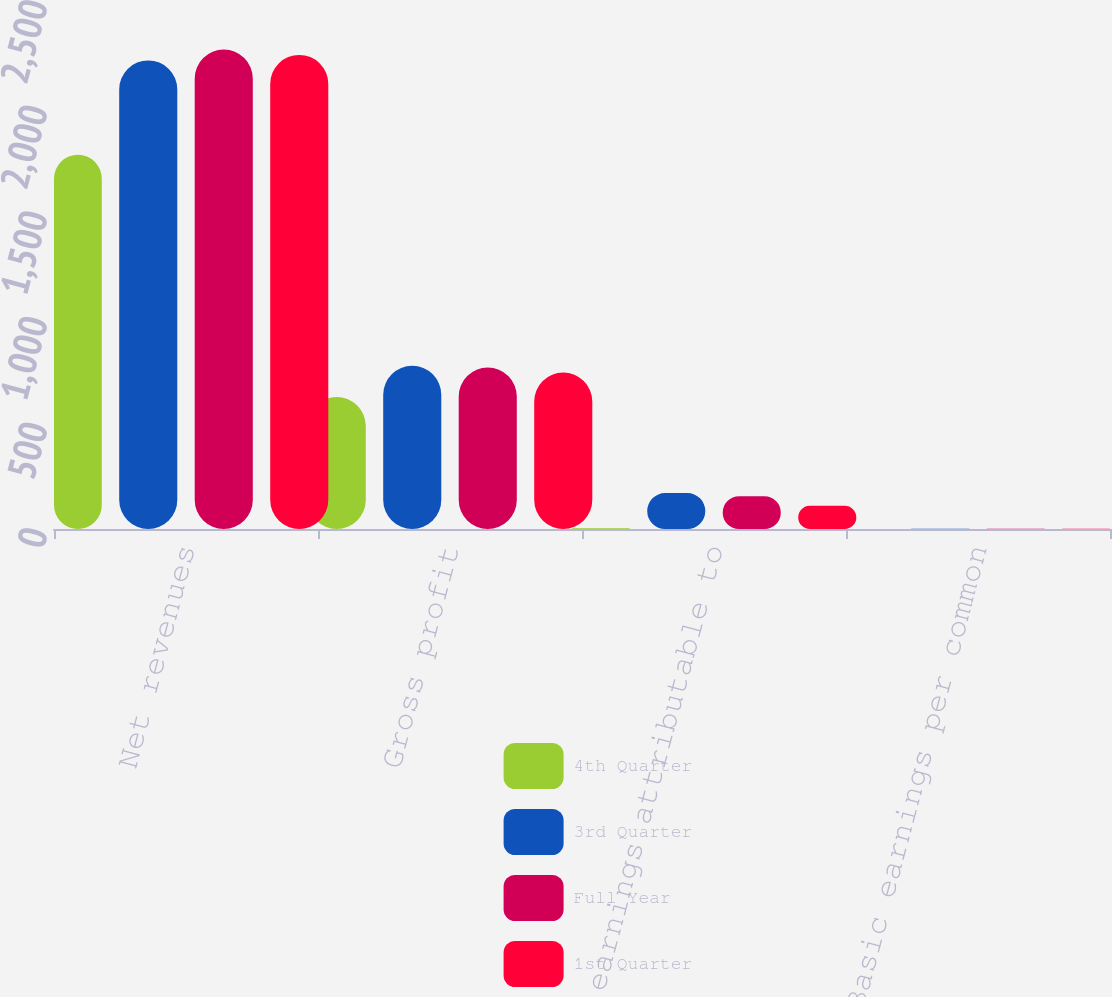<chart> <loc_0><loc_0><loc_500><loc_500><stacked_bar_chart><ecel><fcel>Net revenues<fcel>Gross profit<fcel>Net earnings attributable to<fcel>Basic earnings per common<nl><fcel>4th Quarter<fcel>1772.3<fcel>625.1<fcel>3<fcel>0.04<nl><fcel>3rd Quarter<fcel>2218.7<fcel>772.6<fcel>169.9<fcel>1.69<nl><fcel>Full Year<fcel>2269.9<fcel>764.9<fcel>154.7<fcel>1.53<nl><fcel>1st Quarter<fcel>2244.8<fcel>740.7<fcel>110<fcel>1.09<nl></chart> 